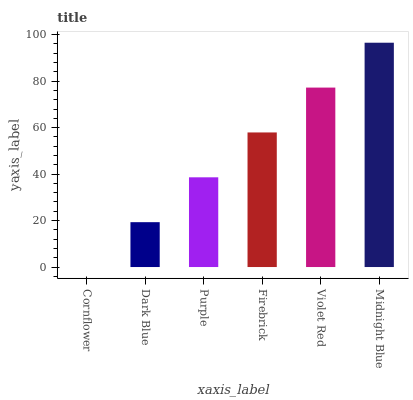Is Cornflower the minimum?
Answer yes or no. Yes. Is Midnight Blue the maximum?
Answer yes or no. Yes. Is Dark Blue the minimum?
Answer yes or no. No. Is Dark Blue the maximum?
Answer yes or no. No. Is Dark Blue greater than Cornflower?
Answer yes or no. Yes. Is Cornflower less than Dark Blue?
Answer yes or no. Yes. Is Cornflower greater than Dark Blue?
Answer yes or no. No. Is Dark Blue less than Cornflower?
Answer yes or no. No. Is Firebrick the high median?
Answer yes or no. Yes. Is Purple the low median?
Answer yes or no. Yes. Is Midnight Blue the high median?
Answer yes or no. No. Is Dark Blue the low median?
Answer yes or no. No. 